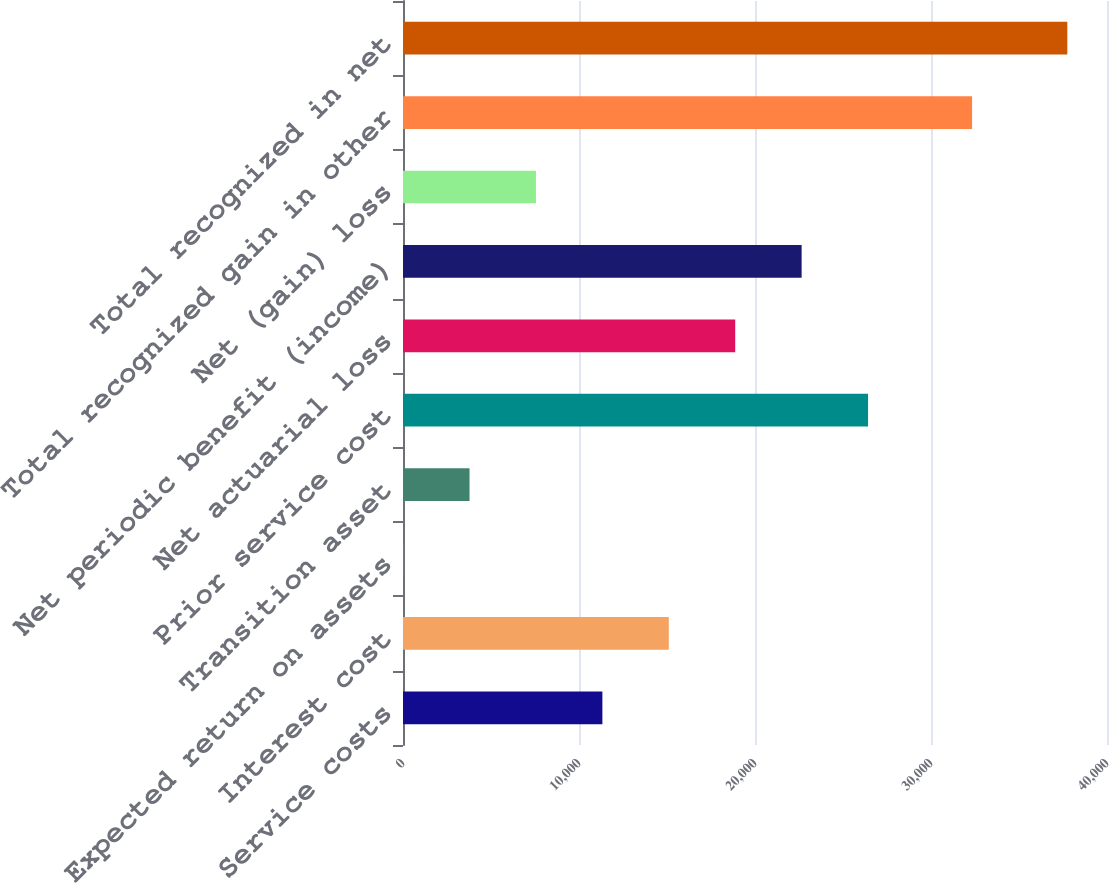<chart> <loc_0><loc_0><loc_500><loc_500><bar_chart><fcel>Service costs<fcel>Interest cost<fcel>Expected return on assets<fcel>Transition asset<fcel>Prior service cost<fcel>Net actuarial loss<fcel>Net periodic benefit (income)<fcel>Net (gain) loss<fcel>Total recognized gain in other<fcel>Total recognized in net<nl><fcel>11328.4<fcel>15102.2<fcel>7<fcel>3780.8<fcel>26423.6<fcel>18876<fcel>22649.8<fcel>7554.6<fcel>32335<fcel>37745<nl></chart> 